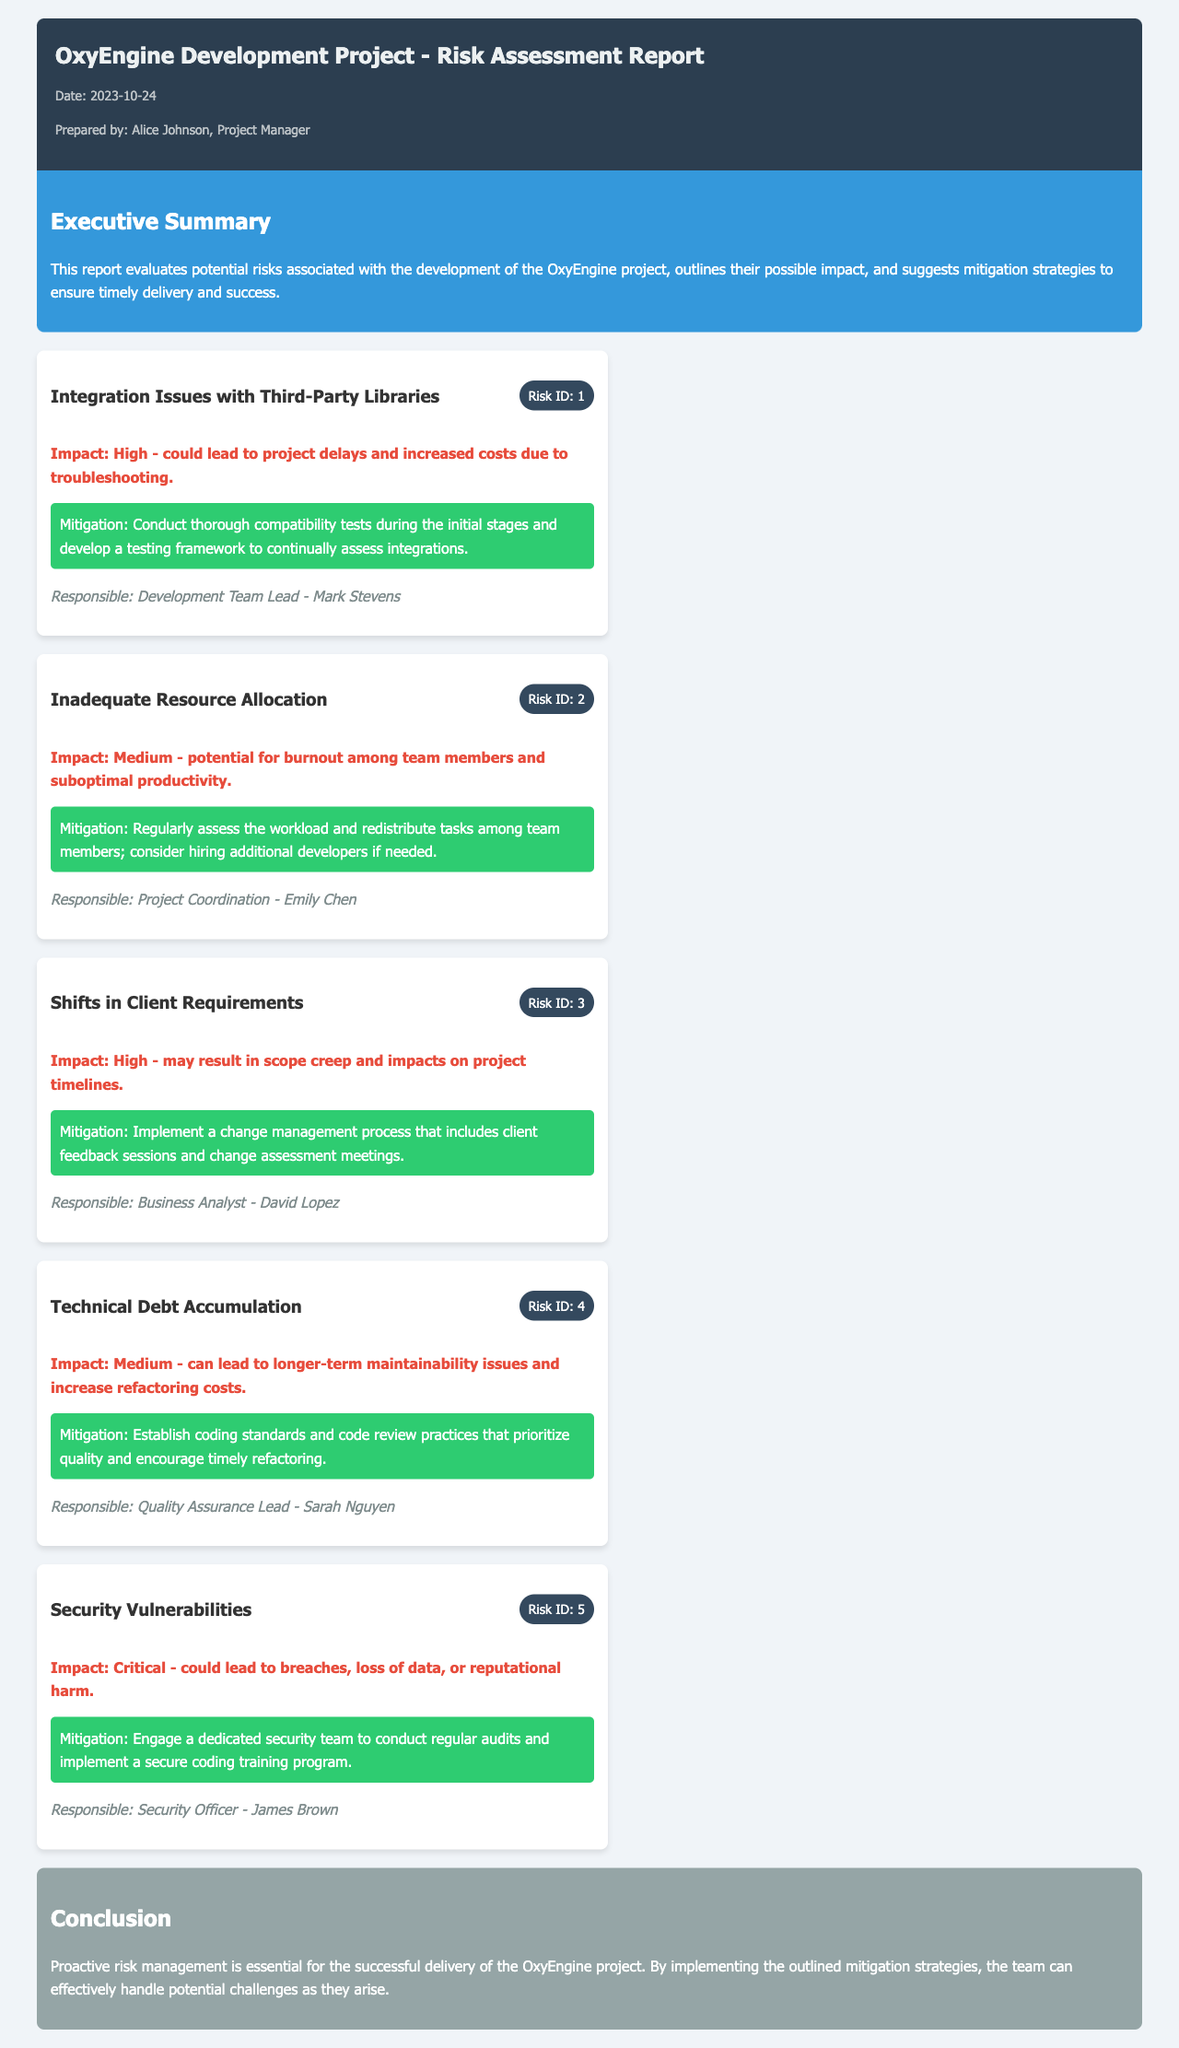What is the date of the report? The date of the report is clearly stated at the top of the document under "Date."
Answer: 2023-10-24 Who is the project manager who prepared the report? The project manager's name is indicated next to "Prepared by" in the meta-info section.
Answer: Alice Johnson What is the impact level of integration issues with third-party libraries? The impact level for this risk is found in the risk card description under impact.
Answer: High What is the mitigation strategy for inadequate resource allocation? The mitigation strategy is summarized in the risk card description regarding that specific risk.
Answer: Regularly assess the workload and redistribute tasks among team members Who is responsible for managing security vulnerabilities? The person responsible is mentioned at the end of the risk card for security vulnerabilities.
Answer: James Brown What risk ID corresponds to shifts in client requirements? The risk ID is displayed in the risk header of that specific risk card.
Answer: 3 What color is the executive summary section? The color of the executive summary section is specified in the document's styling.
Answer: Blue What is the conclusion regarding risk management for the OxyEngine project? The conclusion summarizes the document's stance on risk management in the conclusion section.
Answer: Proactive risk management is essential for the successful delivery of the OxyEngine project 